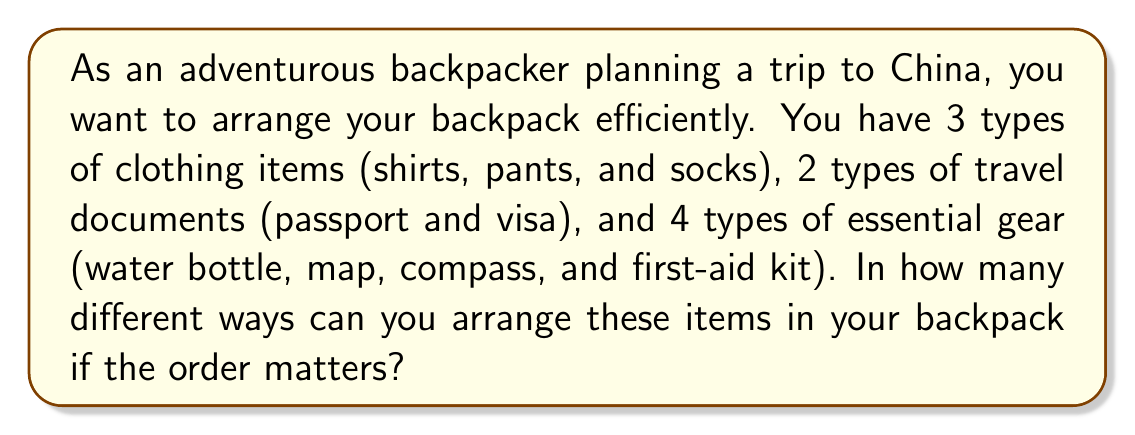What is the answer to this math problem? Let's approach this step-by-step:

1) First, we need to identify the total number of items:
   - 3 types of clothing items
   - 2 types of travel documents
   - 4 types of essential gear
   Total: 3 + 2 + 4 = 9 items

2) Now, we need to arrange these 9 items in the backpack. Since the order matters, this is a permutation problem.

3) The number of ways to arrange n distinct objects is given by n!

4) In this case, we have 9 distinct items, so the number of arrangements is 9!

5) Let's calculate 9!:
   $$9! = 9 \times 8 \times 7 \times 6 \times 5 \times 4 \times 3 \times 2 \times 1 = 362,880$$

Therefore, there are 362,880 different ways to arrange these items in the backpack.
Answer: 362,880 